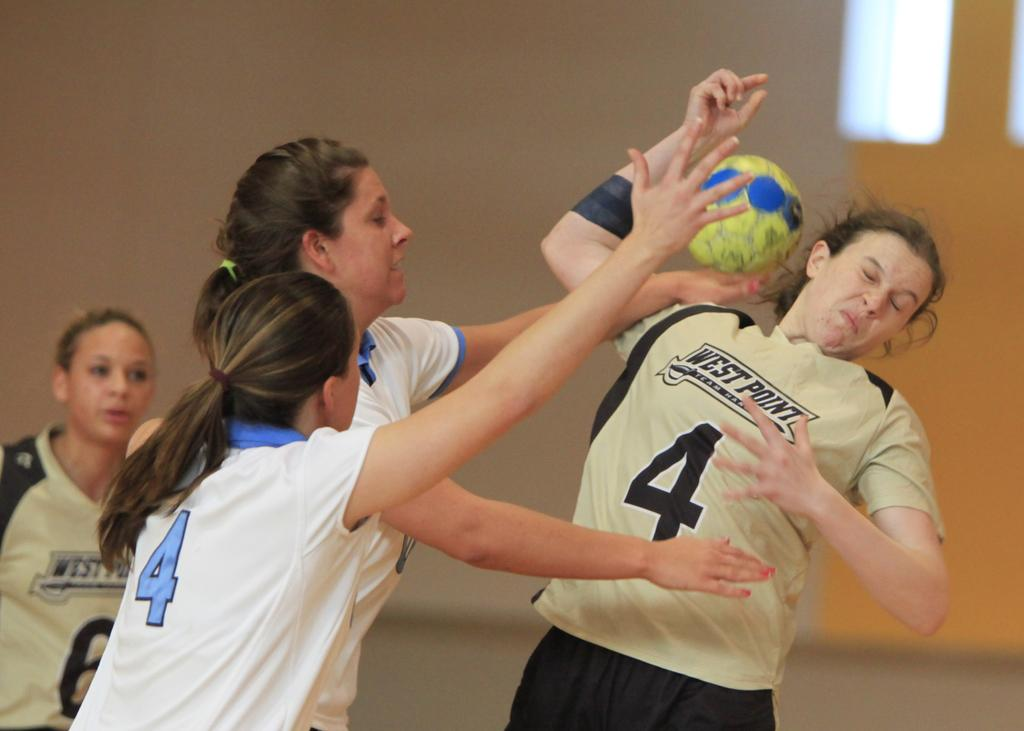What is present in the image that serves as a background or boundary? There is a wall in the image. What is the woman doing in the image? The woman is standing on the floor in the image. What activity is the group of people engaged in? The group of people are playing with a ball. Can you see any bananas being used by the group of people in the image? There are no bananas present in the image; the group of people are playing with a ball. Is the image taken in a bedroom? The provided facts do not mention the location or setting of the image, so it cannot be determined if it is a bedroom or not. 